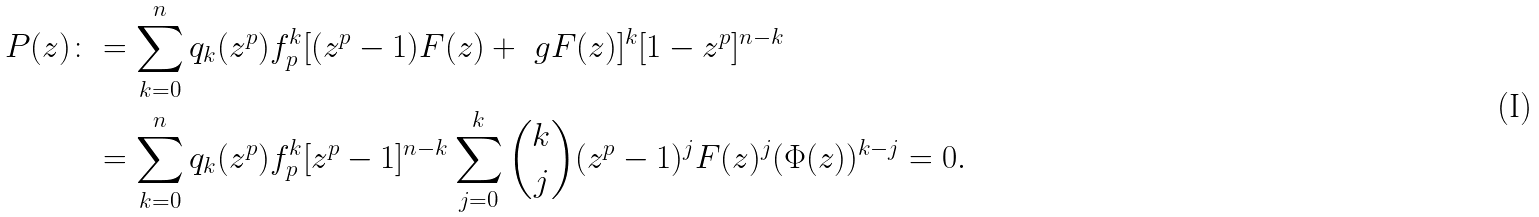<formula> <loc_0><loc_0><loc_500><loc_500>P ( z ) \colon & = \sum _ { k = 0 } ^ { n } q _ { k } ( z ^ { p } ) f _ { p } ^ { k } [ ( z ^ { p } - 1 ) F ( z ) + \ g F ( z ) ] ^ { k } [ 1 - z ^ { p } ] ^ { n - k } \\ & = \sum _ { k = 0 } ^ { n } q _ { k } ( z ^ { p } ) f _ { p } ^ { k } [ z ^ { p } - 1 ] ^ { n - k } \sum _ { j = 0 } ^ { k } { { k } \choose { j } } ( z ^ { p } - 1 ) ^ { j } F ( z ) ^ { j } ( \Phi ( z ) ) ^ { k - j } = 0 .</formula> 